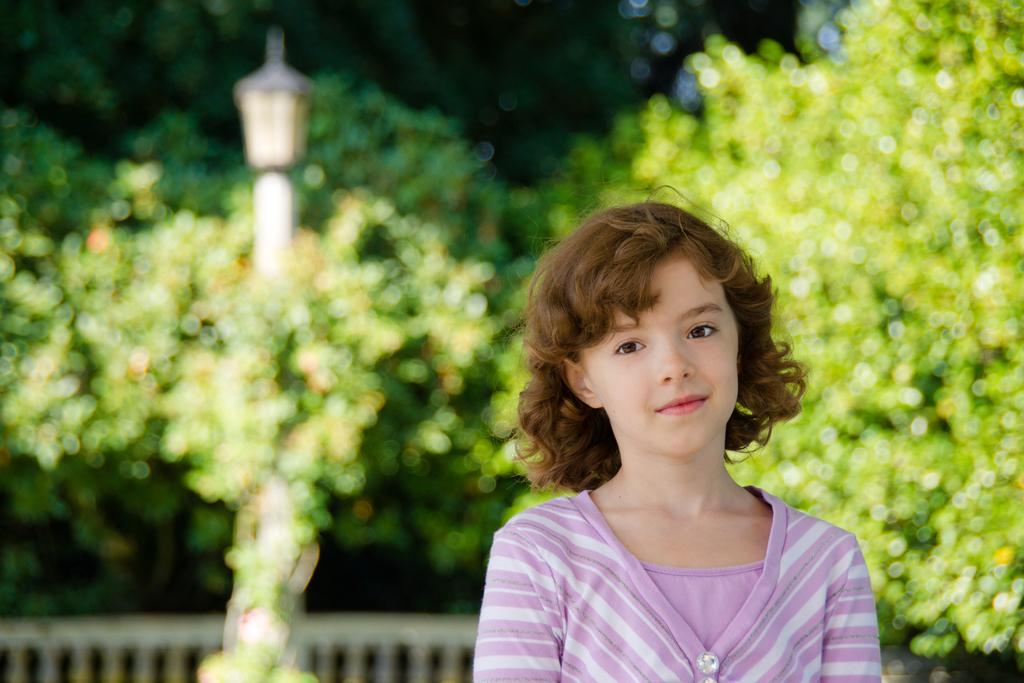Who is the main subject in the picture? There is a girl in the picture. What can be seen in the background of the picture? There are trees, a pole, and a light in the background of the picture. What type of bell can be heard ringing in the picture? There is no bell present in the picture, and therefore no sound can be heard. 